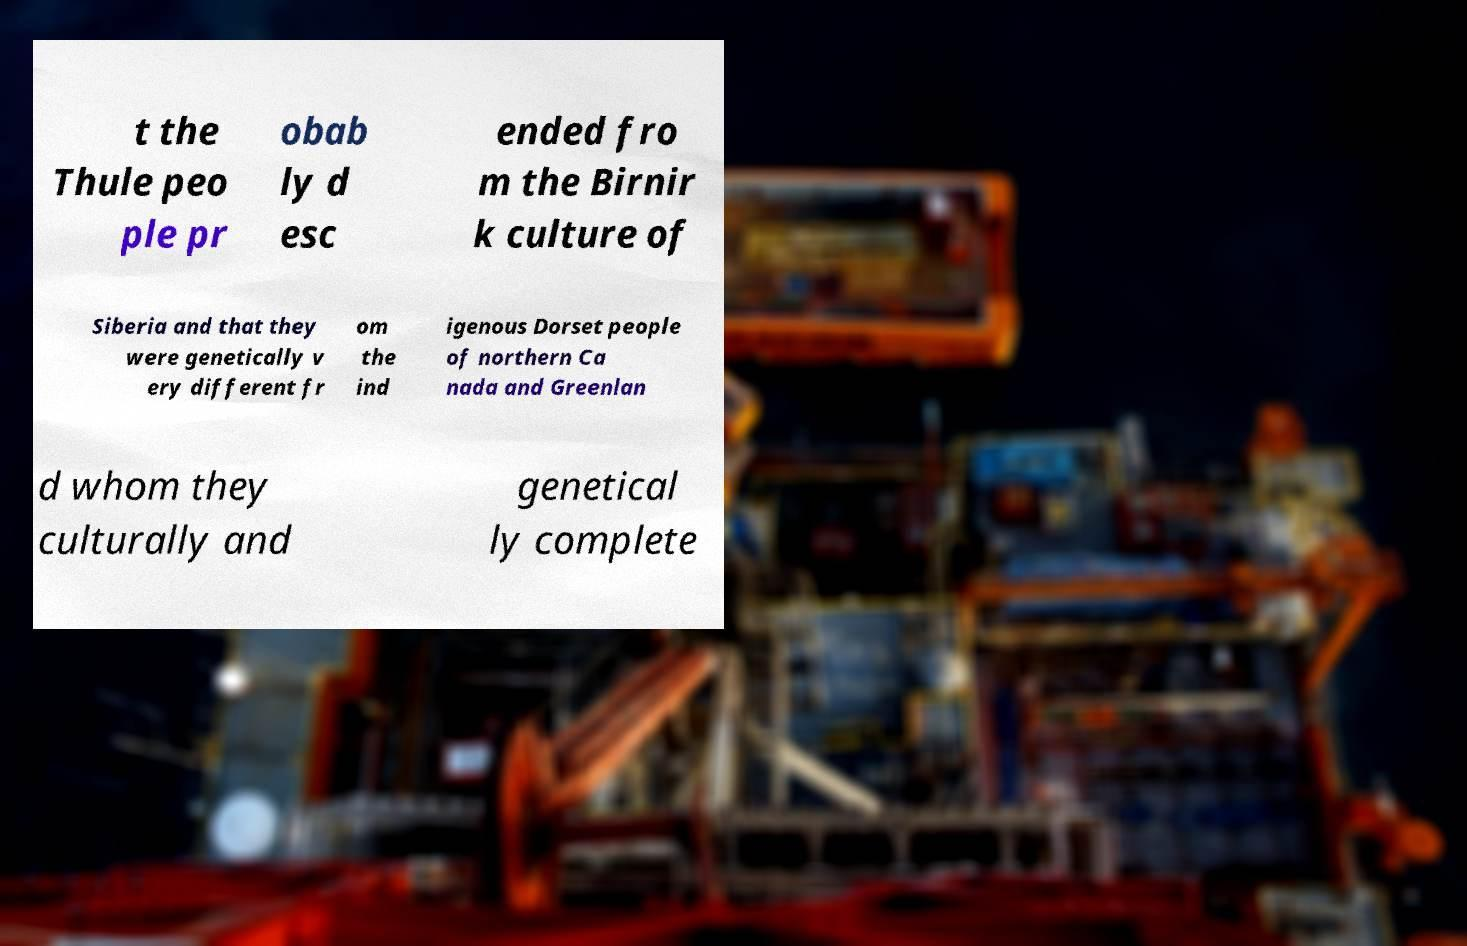Can you accurately transcribe the text from the provided image for me? t the Thule peo ple pr obab ly d esc ended fro m the Birnir k culture of Siberia and that they were genetically v ery different fr om the ind igenous Dorset people of northern Ca nada and Greenlan d whom they culturally and genetical ly complete 